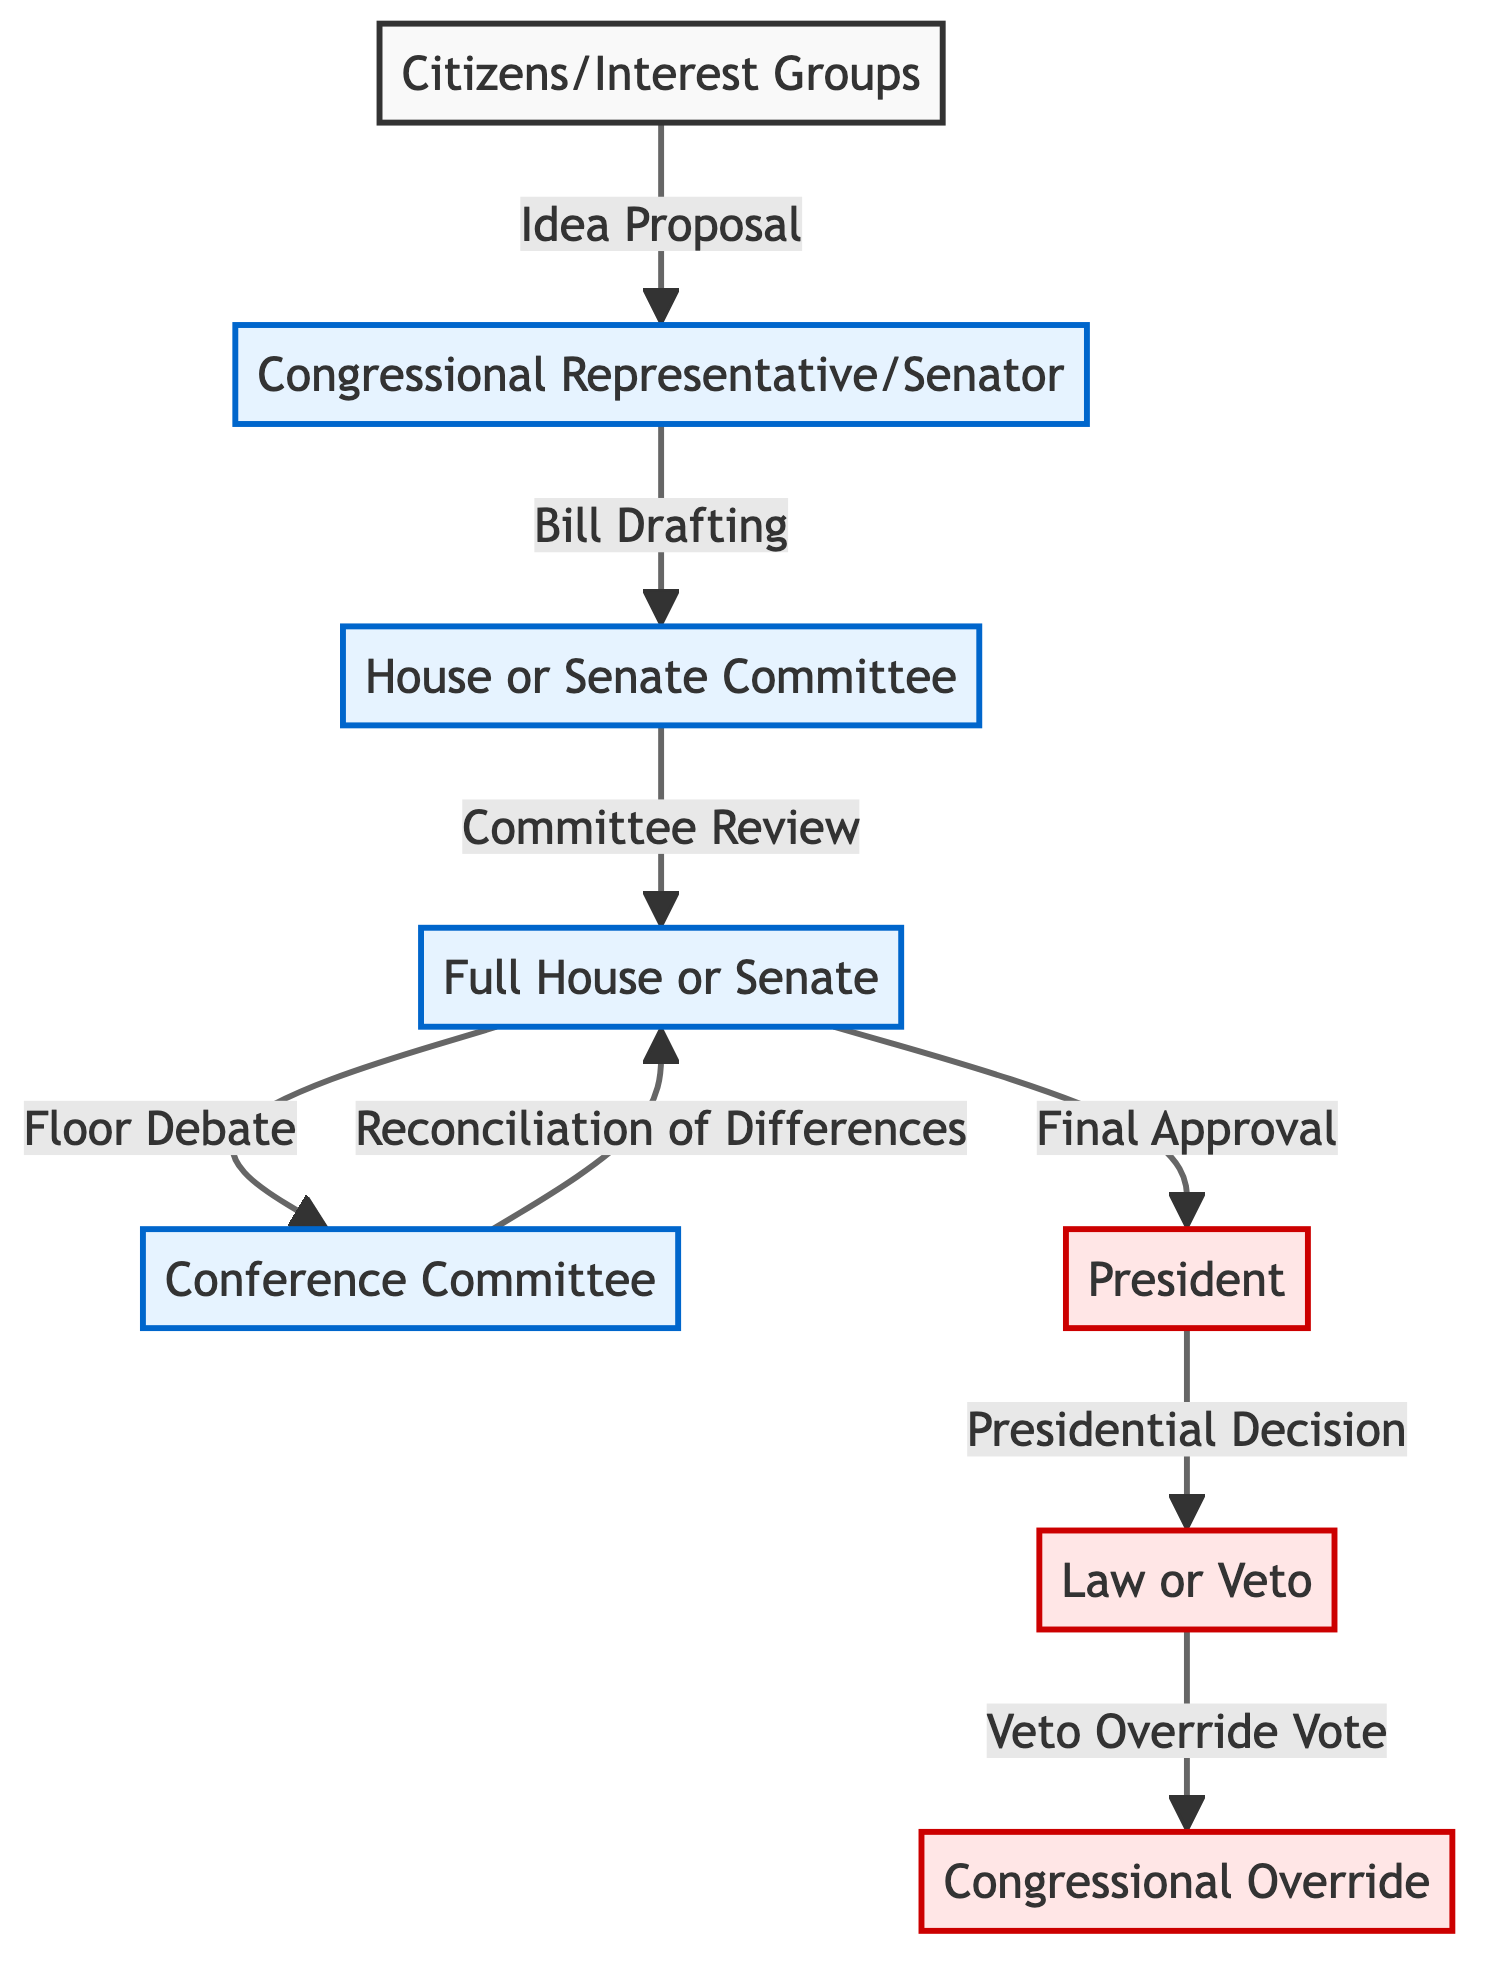What is the first step in the process of how a bill becomes a law? The first step is indicated by the arrow from "Citizens/Interest Groups" to "Congressional Representative/Senator" labeled "Idea Proposal." This shows that citizens or interest groups propose ideas.
Answer: Idea Proposal How many main parties are involved in the bill-making process? The diagram shows three main parties: Citizens/Interest Groups, Congress, and the President. By counting these parties, we see there are three distinct entities involved in the process.
Answer: Three What action occurs after the "Full House or Senate"? The action that follows the "Full House or Senate" is the "Conference Committee," as shown by the arrow connecting the two nodes. This indicates the next step after the full chamber debates and votes.
Answer: Conference Committee What label is given to the process after "Committee Review"? The flowchart specifies that after "Committee Review," the next labeled action is "Floor Debate," demonstrating that the bill is discussed on the chamber floor following committee review.
Answer: Floor Debate Which decision is made by the President? According to the flowchart, the President's decision is whether to approve the bill or issue a veto, labeled as "Presidential Decision." This indicates the pivotal choice the President makes in the legislation process.
Answer: Presidential Decision What is required for Congress to override a veto? The flowchart shows that a veto override requires a vote, labeled "Veto Override Vote," indicating that Congress must vote to override the President's veto for the bill to become law despite it.
Answer: Veto Override Vote What happens during the "Reconciliation of Differences"? "Reconciliation of Differences" occurs in the "Conference Committee," where differences between the House and Senate versions of the bill are resolved before final approval can happen.
Answer: Conference Committee What step comes before the "Final Approval"? Before "Final Approval," the diagram shows "Floor Debate" which implies that the bill is debated on the floor prior to receiving any final vote or approval.
Answer: Floor Debate What is the last possible outcome shown in this process? The last outcome in the diagram is "Law or Veto," indicating that the ultimate result of the process is either that the bill becomes law or it is vetoed by the President.
Answer: Law or Veto 